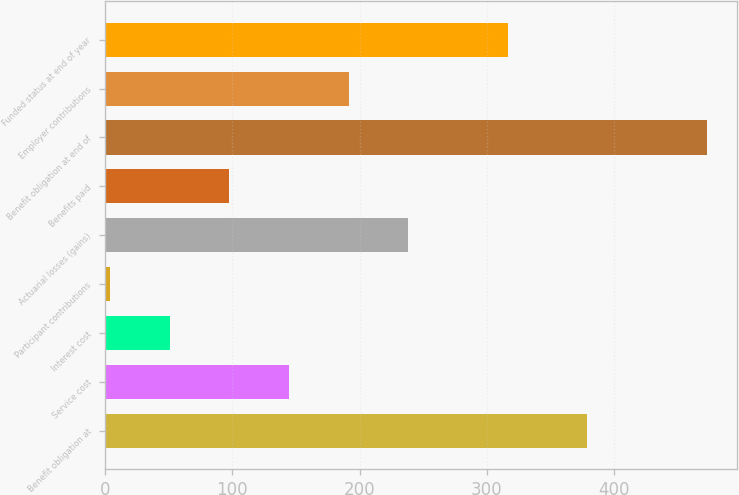<chart> <loc_0><loc_0><loc_500><loc_500><bar_chart><fcel>Benefit obligation at<fcel>Service cost<fcel>Interest cost<fcel>Participant contributions<fcel>Actuarial losses (gains)<fcel>Benefits paid<fcel>Benefit obligation at end of<fcel>Employer contributions<fcel>Funded status at end of year<nl><fcel>378.9<fcel>144.59<fcel>50.73<fcel>3.8<fcel>238.45<fcel>97.66<fcel>473.1<fcel>191.52<fcel>316.3<nl></chart> 